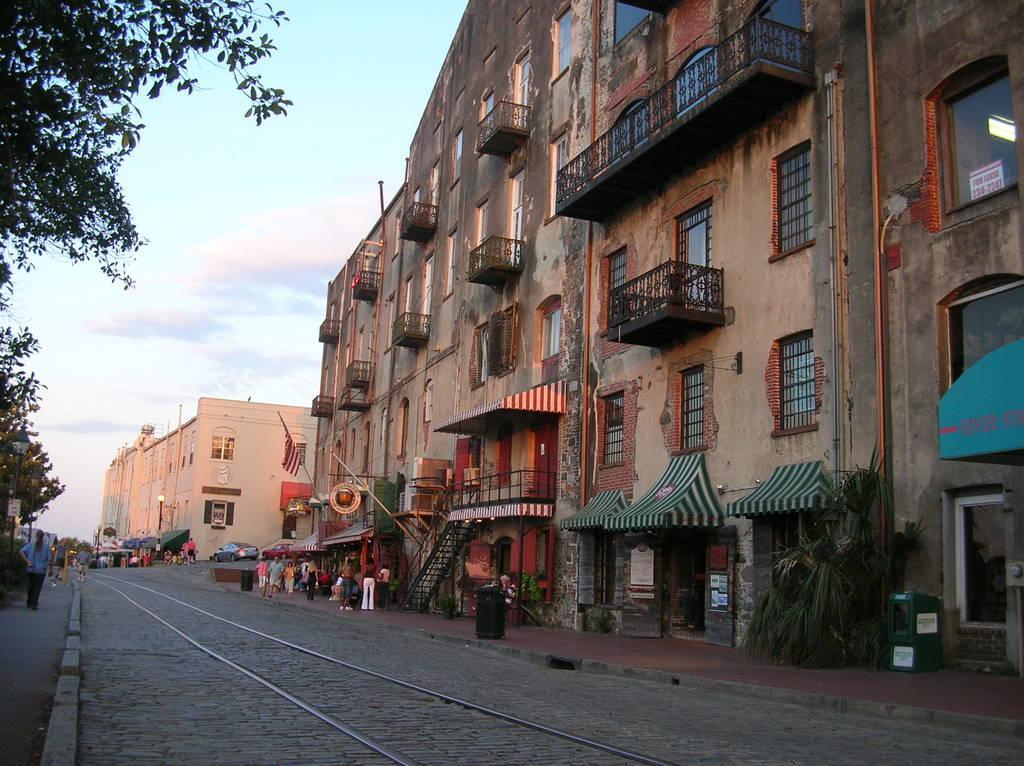Please provide a concise description of this image. In this image there are buildings and there are flags on the buildings, in front of the buildings there are a few people walking on the pavement and there are a few cars parked on the road, in front of the building there is a tram track, beside the tram track there are trees. 